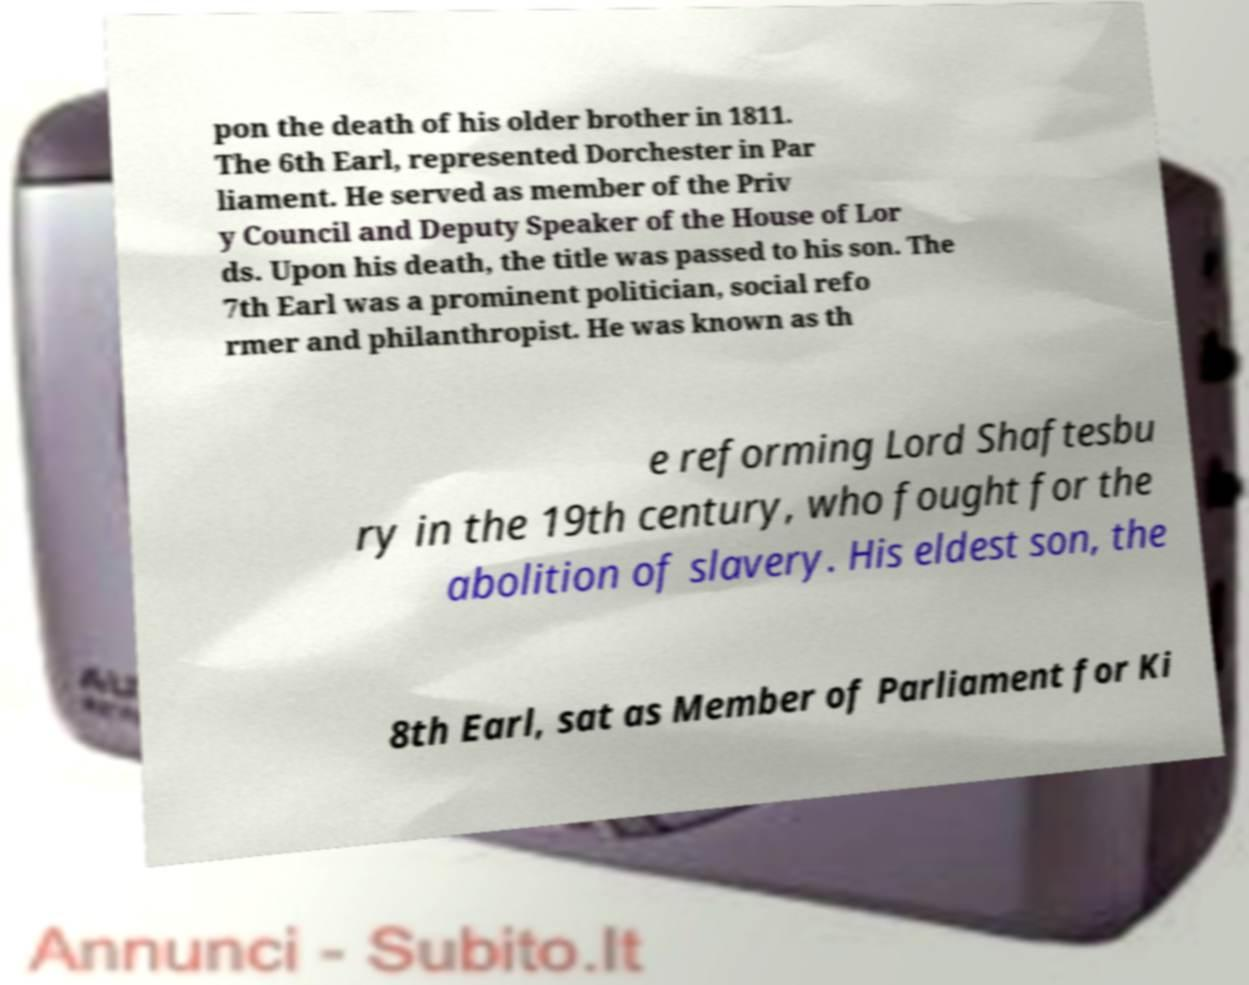Could you extract and type out the text from this image? pon the death of his older brother in 1811. The 6th Earl, represented Dorchester in Par liament. He served as member of the Priv y Council and Deputy Speaker of the House of Lor ds. Upon his death, the title was passed to his son. The 7th Earl was a prominent politician, social refo rmer and philanthropist. He was known as th e reforming Lord Shaftesbu ry in the 19th century, who fought for the abolition of slavery. His eldest son, the 8th Earl, sat as Member of Parliament for Ki 